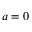<formula> <loc_0><loc_0><loc_500><loc_500>a = 0</formula> 